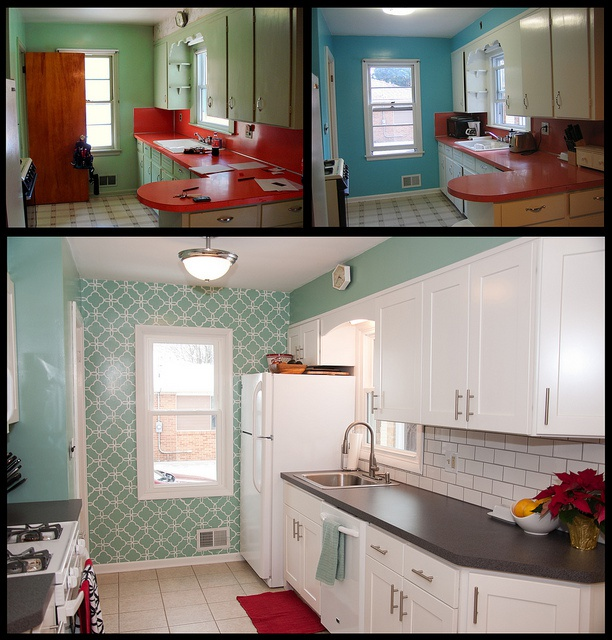Describe the objects in this image and their specific colors. I can see refrigerator in black, lightgray, and darkgray tones, oven in black, gray, and darkgray tones, potted plant in black, maroon, and darkgray tones, refrigerator in black and gray tones, and refrigerator in black, gray, darkgray, and teal tones in this image. 